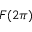Convert formula to latex. <formula><loc_0><loc_0><loc_500><loc_500>F ( 2 \pi )</formula> 